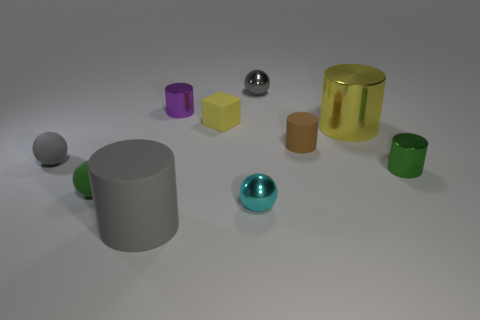There is a green object left of the brown thing; what is its size?
Keep it short and to the point. Small. There is a cyan metal thing; what shape is it?
Your answer should be compact. Sphere. There is a yellow object that is left of the tiny brown cylinder; does it have the same size as the green thing on the right side of the large yellow cylinder?
Provide a succinct answer. Yes. How big is the gray thing that is on the right side of the tiny metallic cylinder that is behind the rubber ball that is behind the green shiny cylinder?
Your answer should be compact. Small. There is a gray matte thing behind the large thing to the left of the gray sphere that is to the right of the tiny yellow block; what shape is it?
Your answer should be compact. Sphere. What is the shape of the large object in front of the brown cylinder?
Offer a terse response. Cylinder. Is the tiny cyan ball made of the same material as the small green object left of the big rubber cylinder?
Provide a short and direct response. No. How many other things are the same shape as the yellow metallic thing?
Keep it short and to the point. 4. Do the small matte block and the shiny ball that is to the right of the cyan sphere have the same color?
Offer a very short reply. No. Is there any other thing that is the same material as the big yellow cylinder?
Provide a succinct answer. Yes. 